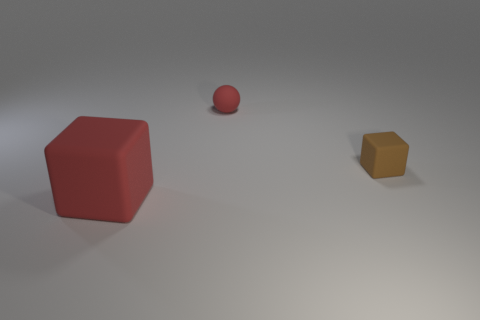There is a small cube; are there any tiny brown objects right of it?
Offer a terse response. No. How many brown things are the same size as the red matte sphere?
Provide a short and direct response. 1. The large thing that is the same color as the small matte ball is what shape?
Make the answer very short. Cube. What material is the tiny object that is in front of the ball?
Ensure brevity in your answer.  Rubber. What number of other small brown things have the same shape as the tiny brown object?
Make the answer very short. 0. There is a tiny red object that is made of the same material as the large red object; what is its shape?
Ensure brevity in your answer.  Sphere. What shape is the red rubber thing that is to the left of the tiny thing to the left of the tiny brown thing that is behind the large red matte block?
Offer a very short reply. Cube. Is the number of big red blocks greater than the number of rubber objects?
Provide a succinct answer. No. Are there more matte things that are in front of the tiny red thing than tiny rubber balls?
Ensure brevity in your answer.  Yes. The cube on the left side of the matte block that is behind the big red block that is left of the brown matte block is made of what material?
Make the answer very short. Rubber. 